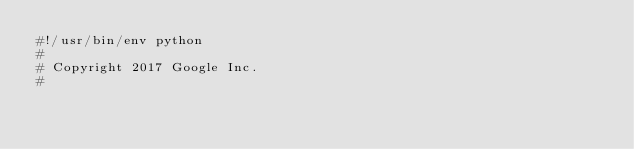<code> <loc_0><loc_0><loc_500><loc_500><_Python_>#!/usr/bin/env python
#
# Copyright 2017 Google Inc.
#</code> 